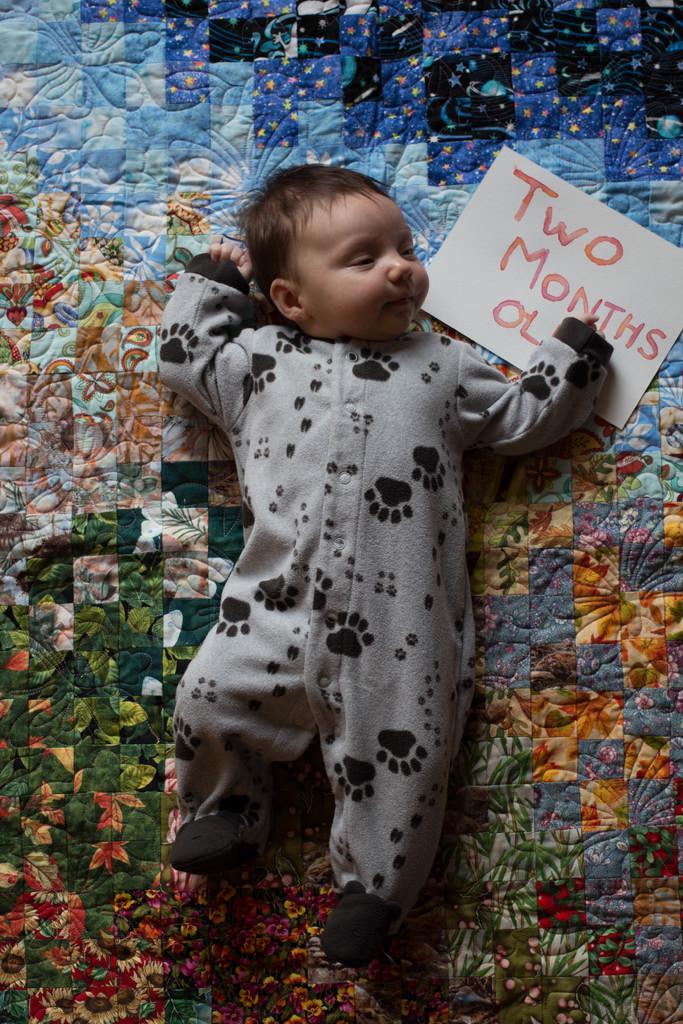In one or two sentences, can you explain what this image depicts? In this picture I can see a baby is sleeping. I can also see a paper on which something written on it. 